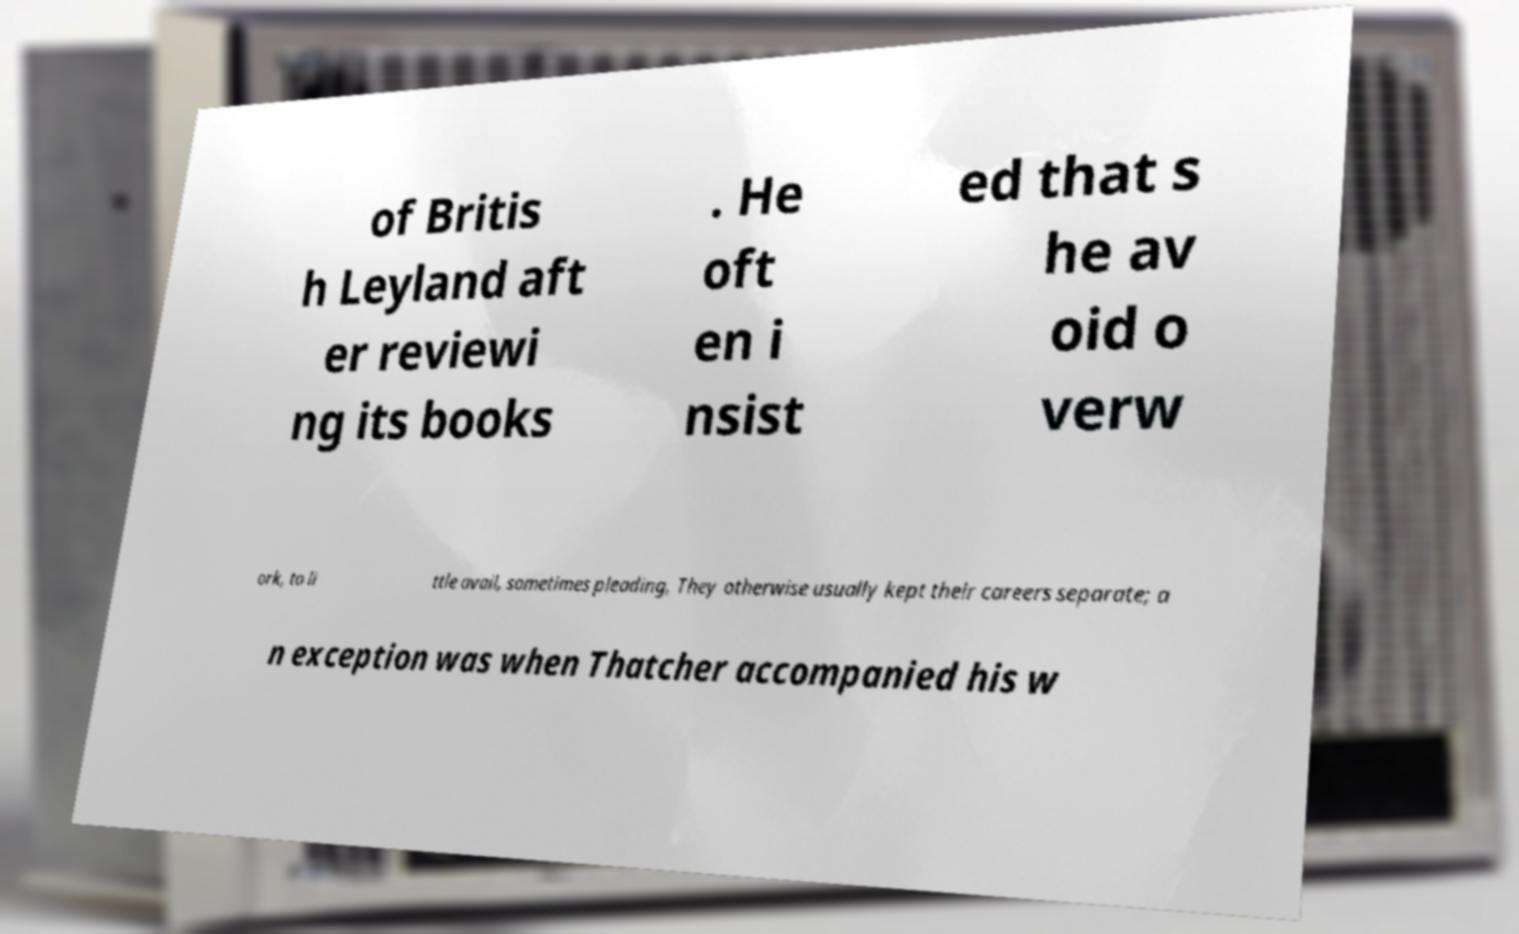There's text embedded in this image that I need extracted. Can you transcribe it verbatim? of Britis h Leyland aft er reviewi ng its books . He oft en i nsist ed that s he av oid o verw ork, to li ttle avail, sometimes pleading, They otherwise usually kept their careers separate; a n exception was when Thatcher accompanied his w 